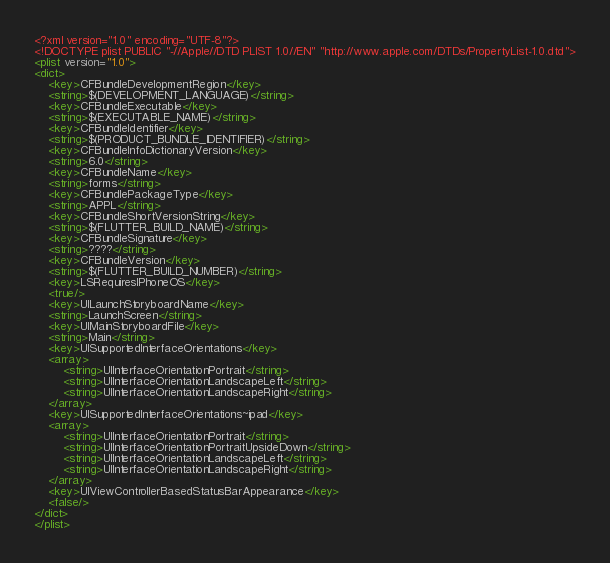Convert code to text. <code><loc_0><loc_0><loc_500><loc_500><_XML_><?xml version="1.0" encoding="UTF-8"?>
<!DOCTYPE plist PUBLIC "-//Apple//DTD PLIST 1.0//EN" "http://www.apple.com/DTDs/PropertyList-1.0.dtd">
<plist version="1.0">
<dict>
	<key>CFBundleDevelopmentRegion</key>
	<string>$(DEVELOPMENT_LANGUAGE)</string>
	<key>CFBundleExecutable</key>
	<string>$(EXECUTABLE_NAME)</string>
	<key>CFBundleIdentifier</key>
	<string>$(PRODUCT_BUNDLE_IDENTIFIER)</string>
	<key>CFBundleInfoDictionaryVersion</key>
	<string>6.0</string>
	<key>CFBundleName</key>
	<string>forms</string>
	<key>CFBundlePackageType</key>
	<string>APPL</string>
	<key>CFBundleShortVersionString</key>
	<string>$(FLUTTER_BUILD_NAME)</string>
	<key>CFBundleSignature</key>
	<string>????</string>
	<key>CFBundleVersion</key>
	<string>$(FLUTTER_BUILD_NUMBER)</string>
	<key>LSRequiresIPhoneOS</key>
	<true/>
	<key>UILaunchStoryboardName</key>
	<string>LaunchScreen</string>
	<key>UIMainStoryboardFile</key>
	<string>Main</string>
	<key>UISupportedInterfaceOrientations</key>
	<array>
		<string>UIInterfaceOrientationPortrait</string>
		<string>UIInterfaceOrientationLandscapeLeft</string>
		<string>UIInterfaceOrientationLandscapeRight</string>
	</array>
	<key>UISupportedInterfaceOrientations~ipad</key>
	<array>
		<string>UIInterfaceOrientationPortrait</string>
		<string>UIInterfaceOrientationPortraitUpsideDown</string>
		<string>UIInterfaceOrientationLandscapeLeft</string>
		<string>UIInterfaceOrientationLandscapeRight</string>
	</array>
	<key>UIViewControllerBasedStatusBarAppearance</key>
	<false/>
</dict>
</plist>
</code> 